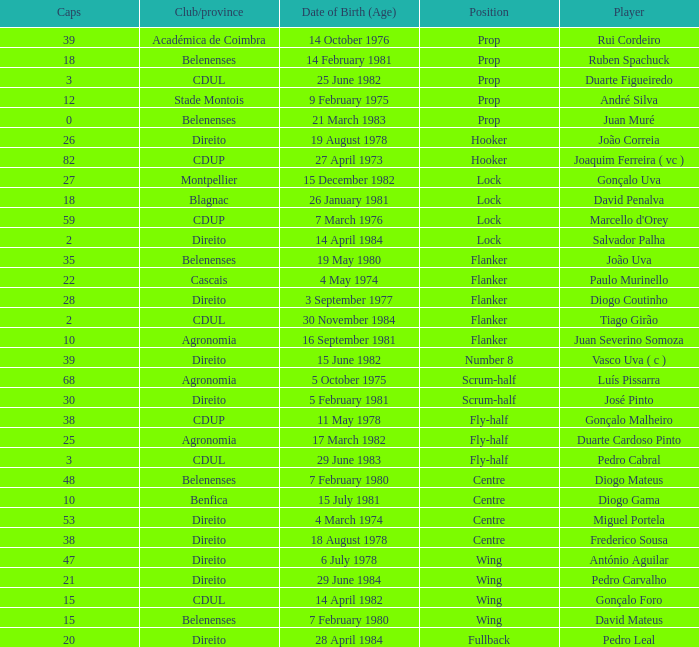Which player has a Club/province of direito, less than 21 caps, and a Position of lock? Salvador Palha. 